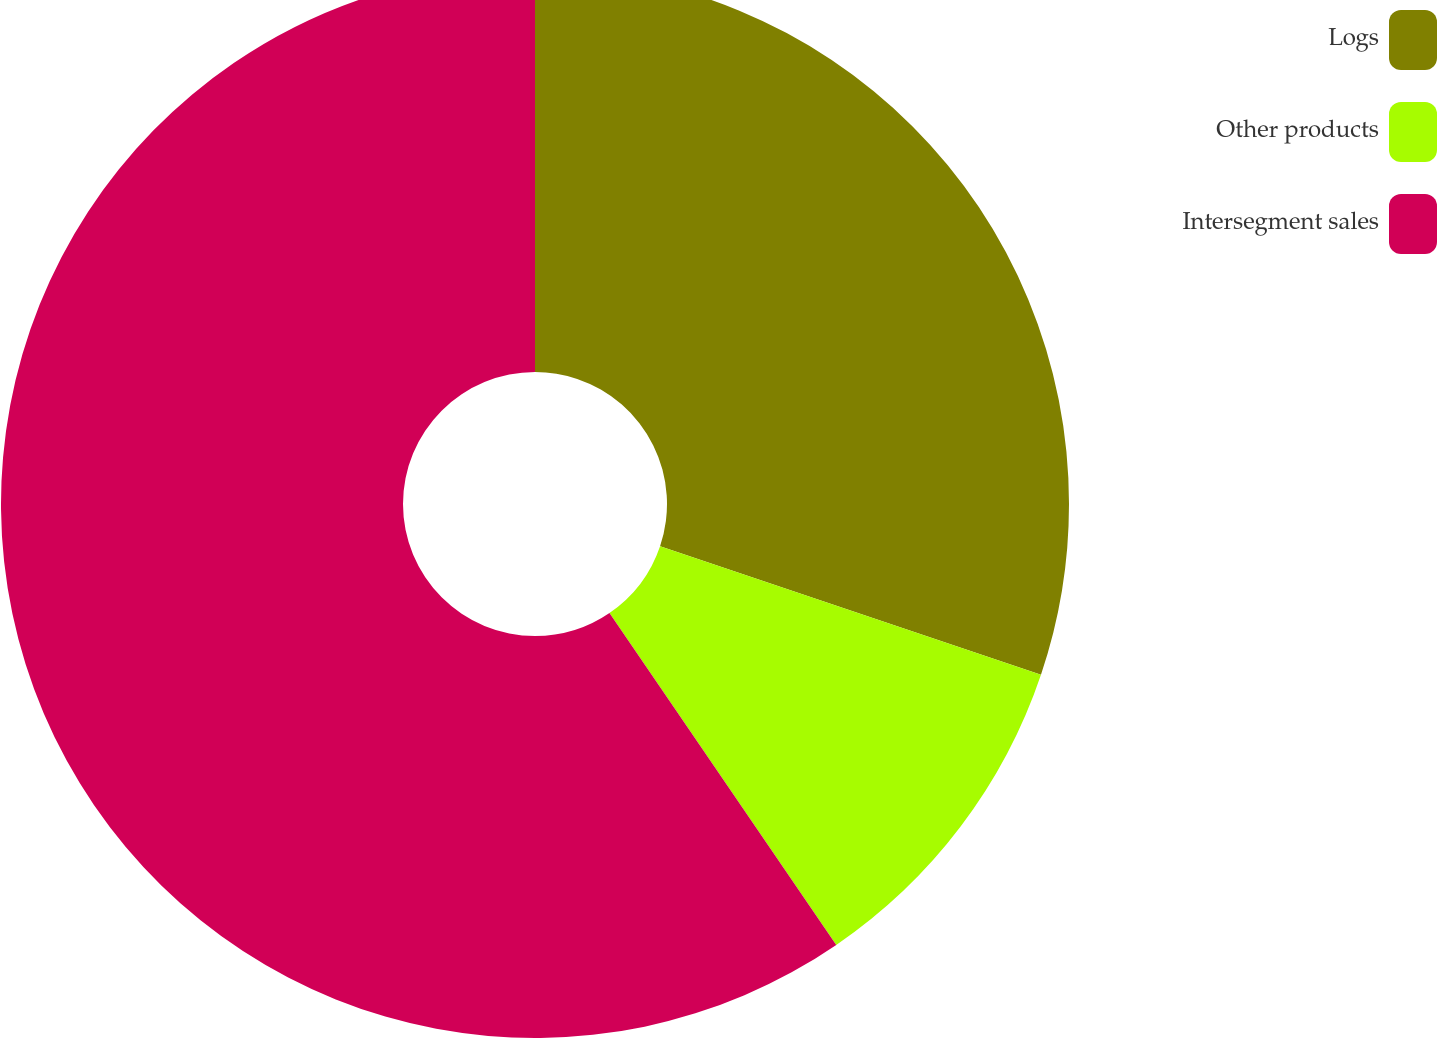Convert chart to OTSL. <chart><loc_0><loc_0><loc_500><loc_500><pie_chart><fcel>Logs<fcel>Other products<fcel>Intersegment sales<nl><fcel>30.18%<fcel>10.28%<fcel>59.54%<nl></chart> 